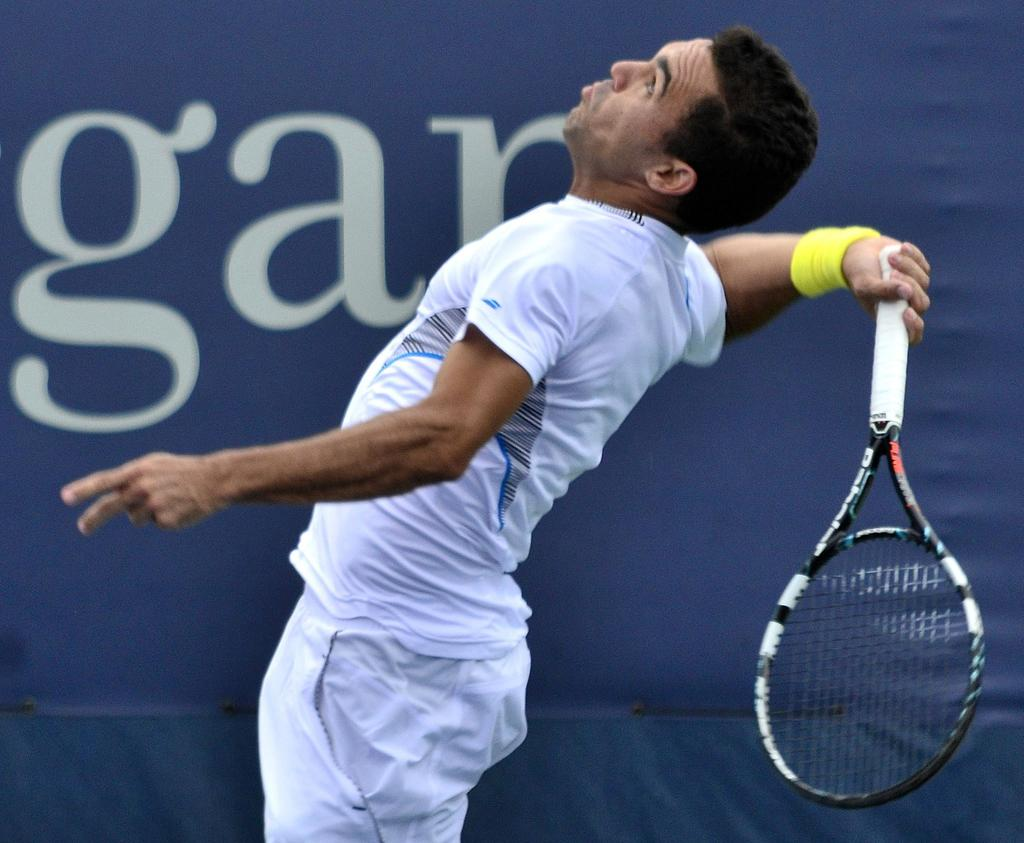Who is present in the image? There is a man in the image. What is the man holding in his hand? The man is holding a racket with his hand. What else can be seen in the image besides the man and the racket? There is a banner in the image. What type of loaf is the man holding in the image? There is no loaf present in the image; the man is holding a racket. Can you describe the maid's uniform in the image? There is no maid present in the image, only a man holding a racket and a banner. 